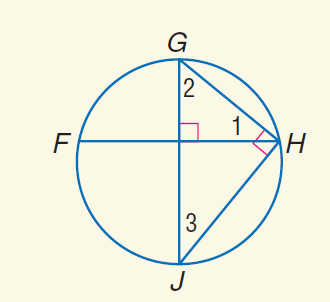Answer the mathemtical geometry problem and directly provide the correct option letter.
Question: m \angle 2 = 2 x, m \angle 3 = x. Find m \angle 1.
Choices: A: 30 B: 39 C: 78 D: 114 A 